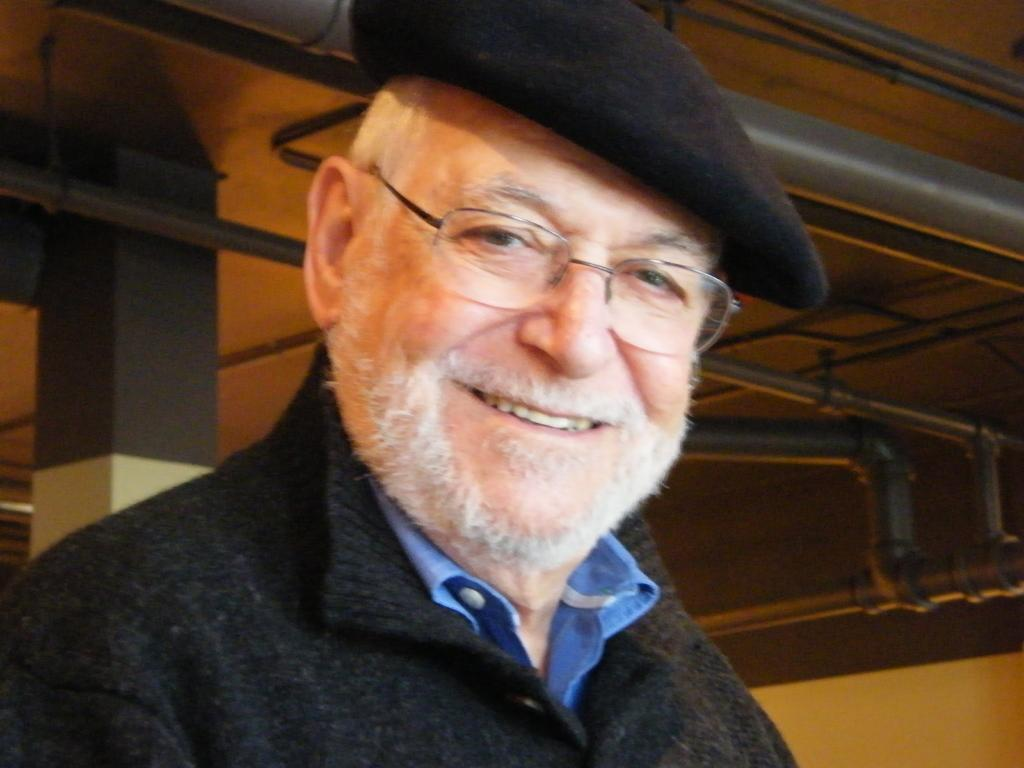What is the main subject of the image? There is a person standing in the center of the image. Can you describe the person's appearance? The person is wearing spectacles and a cap. What can be seen in the background of the image? There are pipes, a pillar, and a wall in the background of the image. What type of thunder can be heard in the image? There is no sound present in the image, so it is not possible to determine if any thunder can be heard. 